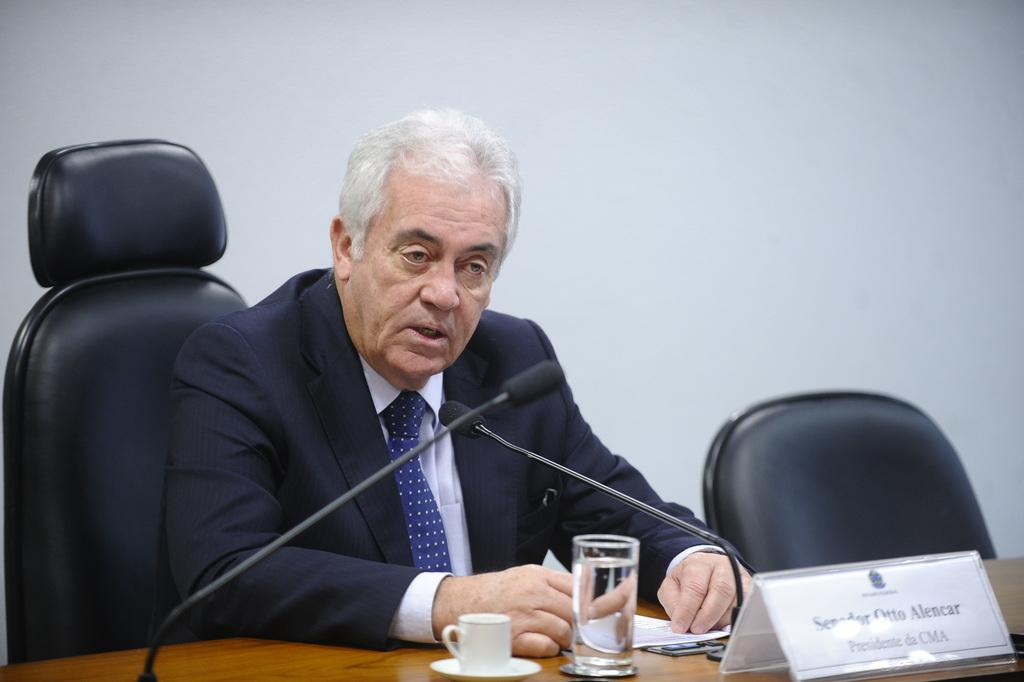What is the person in the image doing? The person is sitting on a chair in the image. What can be seen on the table in the image? There is a cup, a glass of water, papers, a name board, and mics on the table. Are there any other objects on the table? Yes, there are other objects on the table. What is visible in the background of the image? There is a wall in the background of the image. Can you tell me how many volleyballs are on the table in the image? There are no volleyballs present on the table in the image. Is the person running in the image? The person is sitting in the image, not running. 